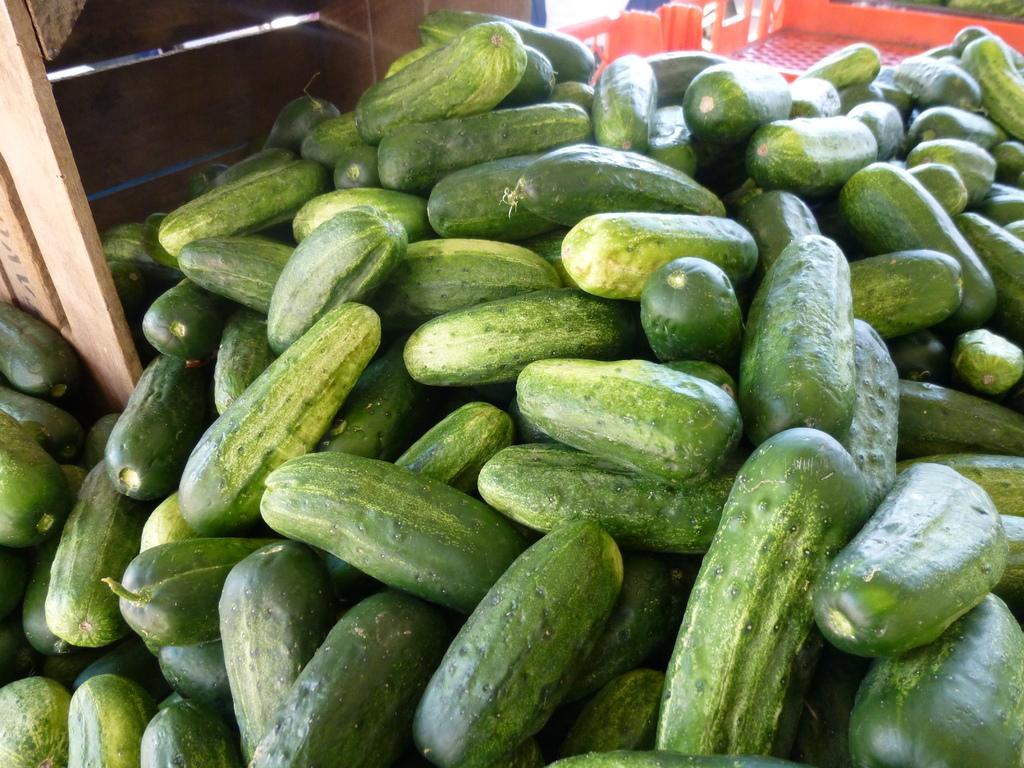Could you give a brief overview of what you see in this image? In the foreground of the picture there are cucumbers and a wooden basket. At the top there are plastic trays. 